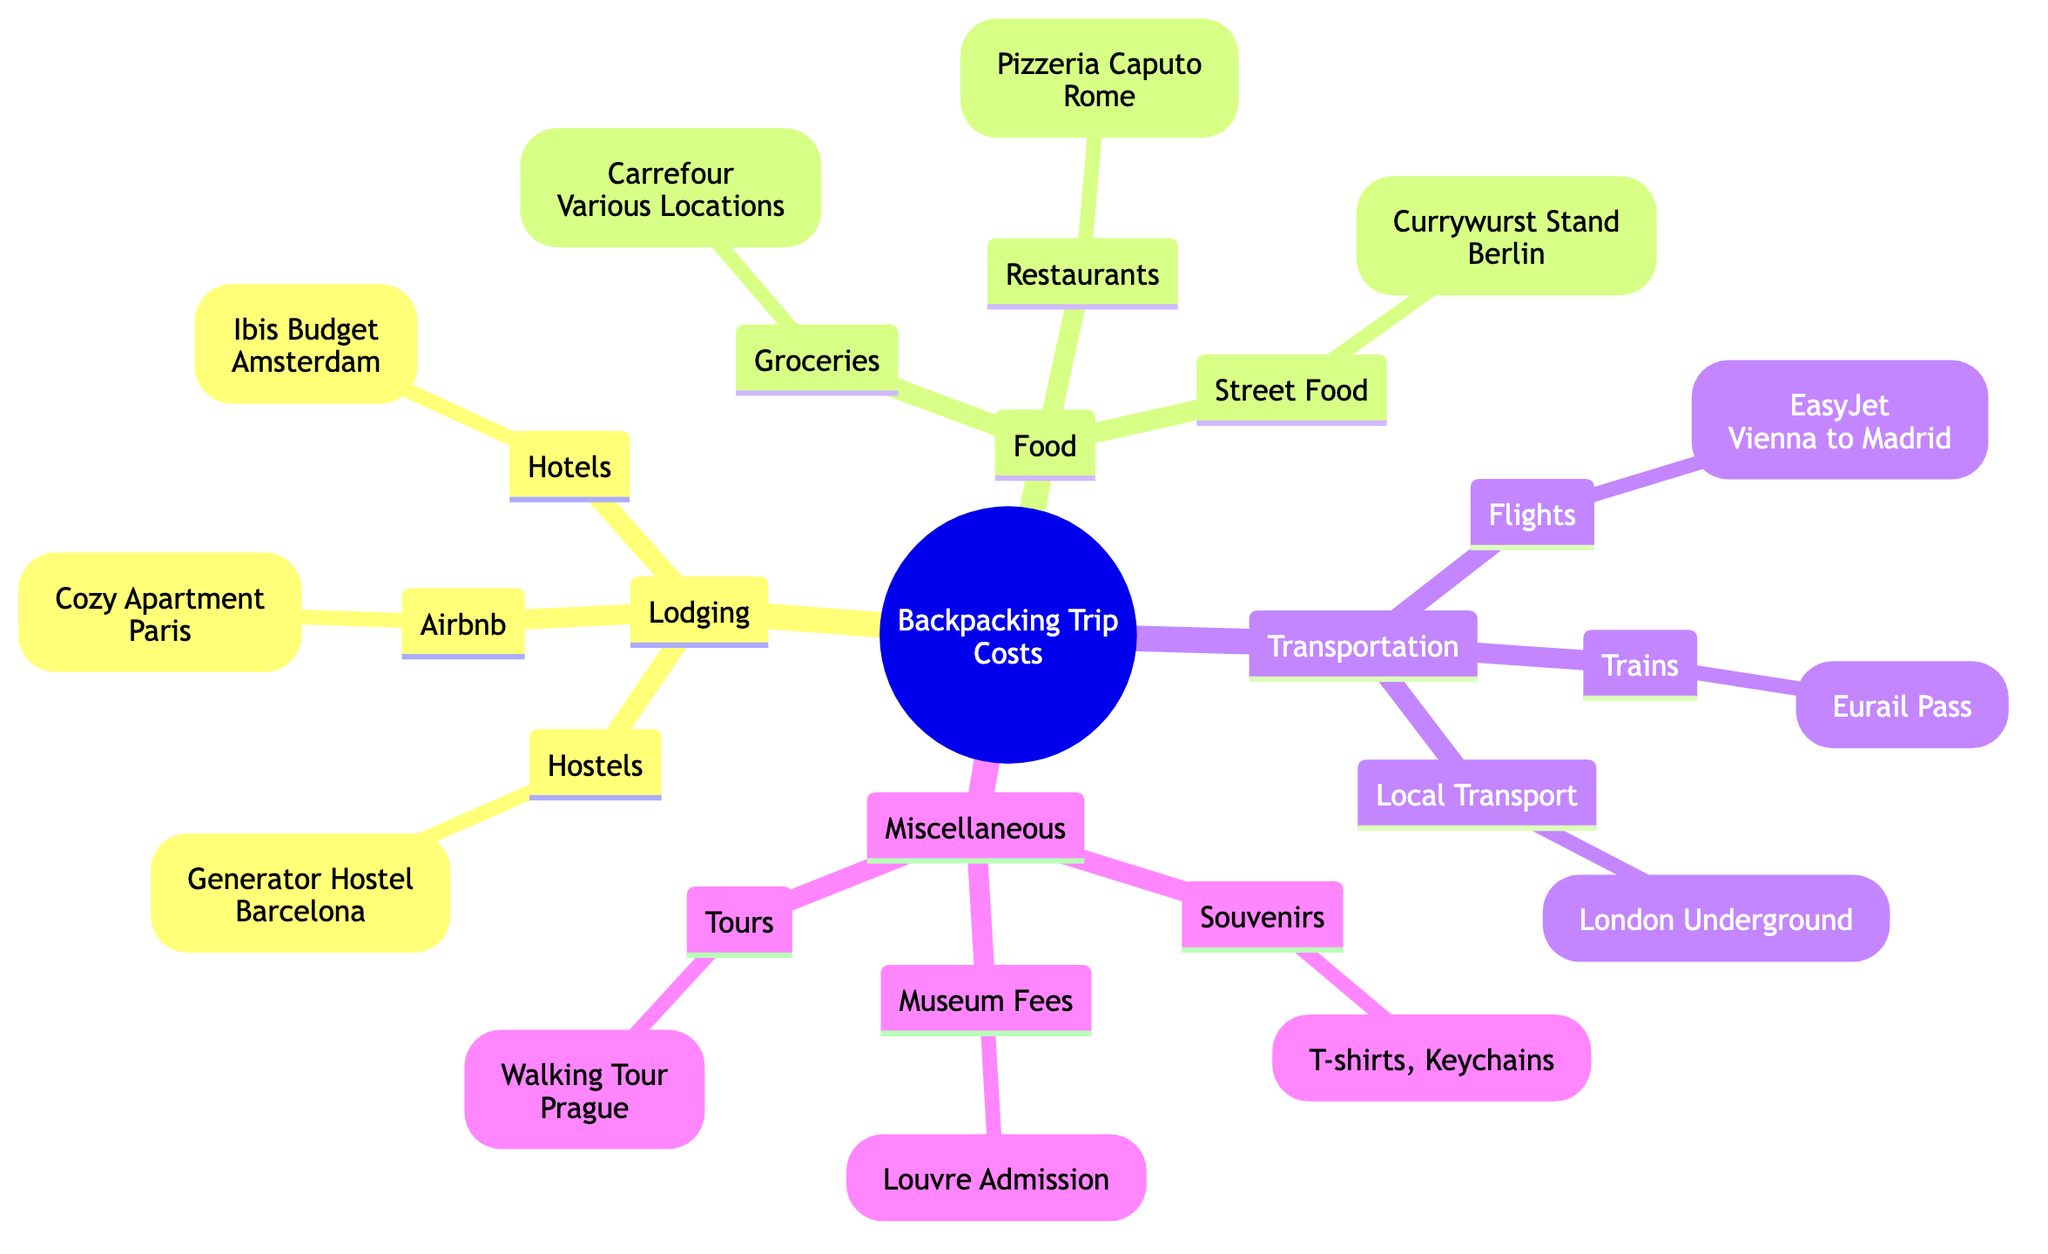What are the main categories of expenses in the backpacking trip? The diagram outlines four main categories of expenses: Lodging, Food, Transportation, and Miscellaneous Expenses. These categories are the primary divisions under which various specific expenses are listed.
Answer: Lodging, Food, Transportation, Miscellaneous Expenses How many types of lodging are mentioned in the diagram? The diagram lists three types of lodging: Hostels, Airbnb, and Hotels. By counting each type under the main category of Lodging, we can derive the total number of lodging types in the trip.
Answer: 3 Which city is associated with the "Generator Hostel"? The "Generator Hostel" is linked to "Barcelona" in the diagram. This information is directly visible under the Hostels section, where each specific lodging type is identified along with its corresponding city.
Answer: Barcelona What type of food expense has a specific location mentioned in Rome? The "Restaurants" category includes "Pizzeria Caputo," which is located in Rome. By focusing on the Food section, we can identify that this specific restaurant falls under the Restaurants type, with Rome as its location.
Answer: Pizzeria Caputo How many means of transportation are listed in the diagram? The diagram presents three means of transportation: Trains, Flights, and Local Transport. By counting the entries under the Transportation category, we determine the total number of transportation means.
Answer: 3 Which category includes "Museum Fees"? "Museum Fees" fall under the Miscellaneous category. By reviewing the individual expense types listed within each main category, we can accurately assign it to Miscellaneous.
Answer: Miscellaneous Which lodging option is listed as an Airbnb? The lodging option categorized as Airbnb is "Cozy Apartment" located in Paris. This specific listing can be extracted from the Airbnb section under the broader Lodging category in the diagram.
Answer: Cozy Apartment What expense type includes "Walking Tour"? The expense type that includes "Walking Tour" is categorized as Tours under Miscellaneous. By examining the Miscellaneous section, we see Tours mentioned with Walking Tour as a specific expense.
Answer: Tours 